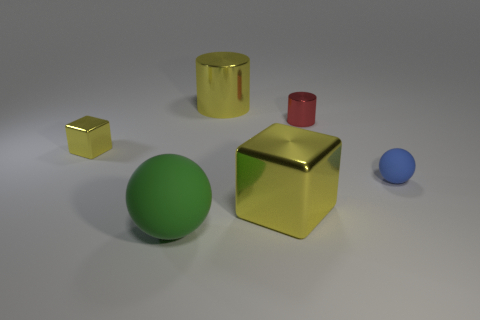Is the color of the small cylinder the same as the metallic block to the left of the green object?
Offer a very short reply. No. What number of objects are yellow metal things that are behind the tiny blue rubber object or small objects right of the large yellow shiny cube?
Provide a succinct answer. 4. There is a large thing that is in front of the small red metal cylinder and behind the large green rubber sphere; what is its color?
Your answer should be very brief. Yellow. Is the number of tiny blue things greater than the number of tiny yellow rubber cubes?
Provide a succinct answer. Yes. There is a big yellow shiny thing that is behind the tiny metallic cube; is it the same shape as the small blue matte thing?
Provide a succinct answer. No. How many metal things are brown blocks or big spheres?
Keep it short and to the point. 0. Are there any large green balls that have the same material as the yellow cylinder?
Provide a short and direct response. No. What is the material of the blue thing?
Offer a terse response. Rubber. What is the shape of the big yellow thing to the right of the large thing behind the ball to the right of the small red cylinder?
Provide a succinct answer. Cube. Is the number of metal cubes that are behind the small yellow metal object greater than the number of brown matte cylinders?
Provide a short and direct response. No. 